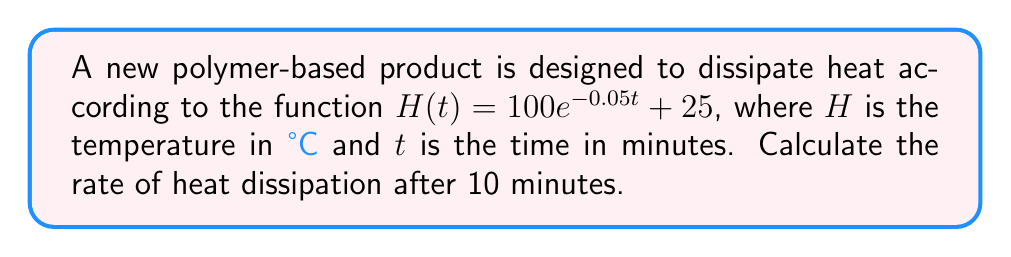Solve this math problem. To find the rate of heat dissipation, we need to calculate the derivative of the given function and evaluate it at t = 10 minutes.

Step 1: Find the derivative of $H(t)$.
$$\frac{d}{dt}H(t) = \frac{d}{dt}(100e^{-0.05t} + 25)$$
$$H'(t) = 100 \cdot (-0.05)e^{-0.05t} + 0$$
$$H'(t) = -5e^{-0.05t}$$

Step 2: Evaluate $H'(t)$ at t = 10 minutes.
$$H'(10) = -5e^{-0.05(10)}$$
$$H'(10) = -5e^{-0.5}$$
$$H'(10) \approx -3.03$$

Step 3: Interpret the result.
The negative value indicates that the temperature is decreasing. The rate of heat dissipation after 10 minutes is approximately 3.03°C per minute.
Answer: $-3.03°C/min$ 